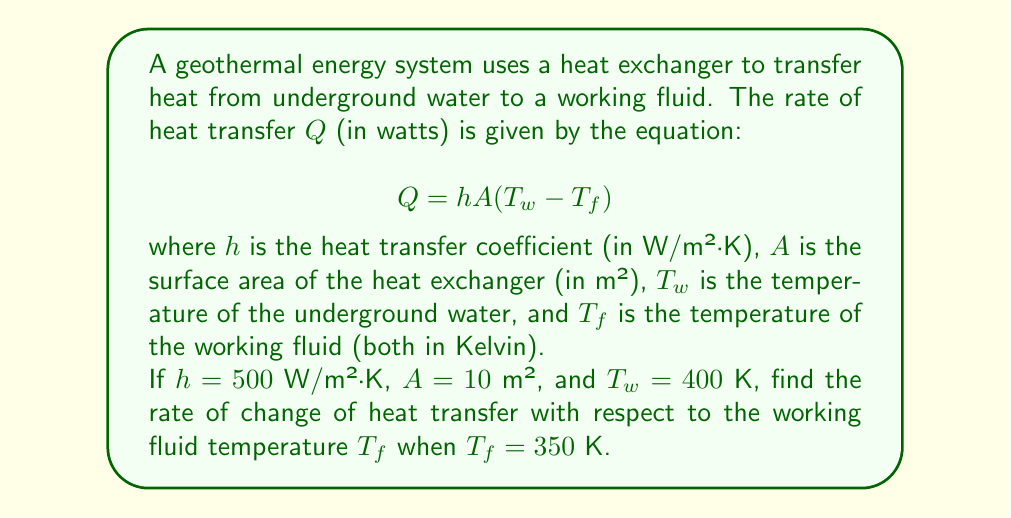Can you solve this math problem? To solve this problem, we need to use differentiation. Let's approach this step-by-step:

1) First, let's identify the function we need to differentiate. In this case, it's:

   $$Q = hA(T_w - T_f)$$

2) We need to find $\frac{dQ}{dT_f}$. Notice that $h$, $A$, and $T_w$ are constants, and $T_f$ is our variable.

3) Applying the differentiation rule:

   $$\frac{dQ}{dT_f} = hA \cdot \frac{d}{dT_f}(T_w - T_f)$$

4) The derivative of a constant ($T_w$) is 0, and the derivative of $-T_f$ with respect to $T_f$ is -1:

   $$\frac{dQ}{dT_f} = hA \cdot (-1) = -hA$$

5) Now we can substitute the given values:

   $$\frac{dQ}{dT_f} = -(500 \text{ W/m²·K})(10 \text{ m²}) = -5000 \text{ W/K}$$

6) The negative sign indicates that as the working fluid temperature increases, the heat transfer rate decreases, which makes physical sense as the temperature difference drives heat transfer.
Answer: $-5000$ W/K 